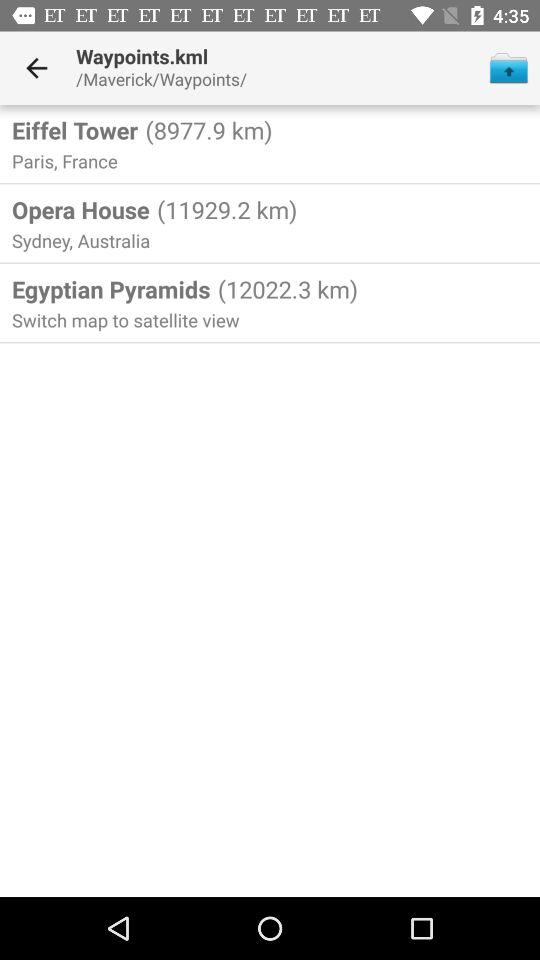What are the mentioned locations? The mentioned locations are Paris, France and Sydney, Australia. 